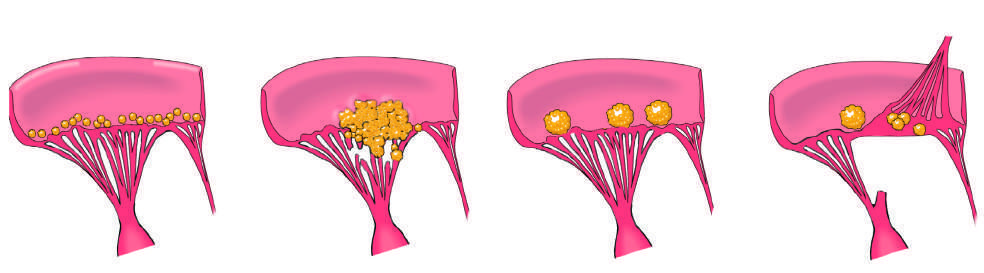does non-bacterial thrombotic endocarditis manifest with small - to medium-sized, bland, nondestructive vegetations at the line of valve closure?
Answer the question using a single word or phrase. Yes 